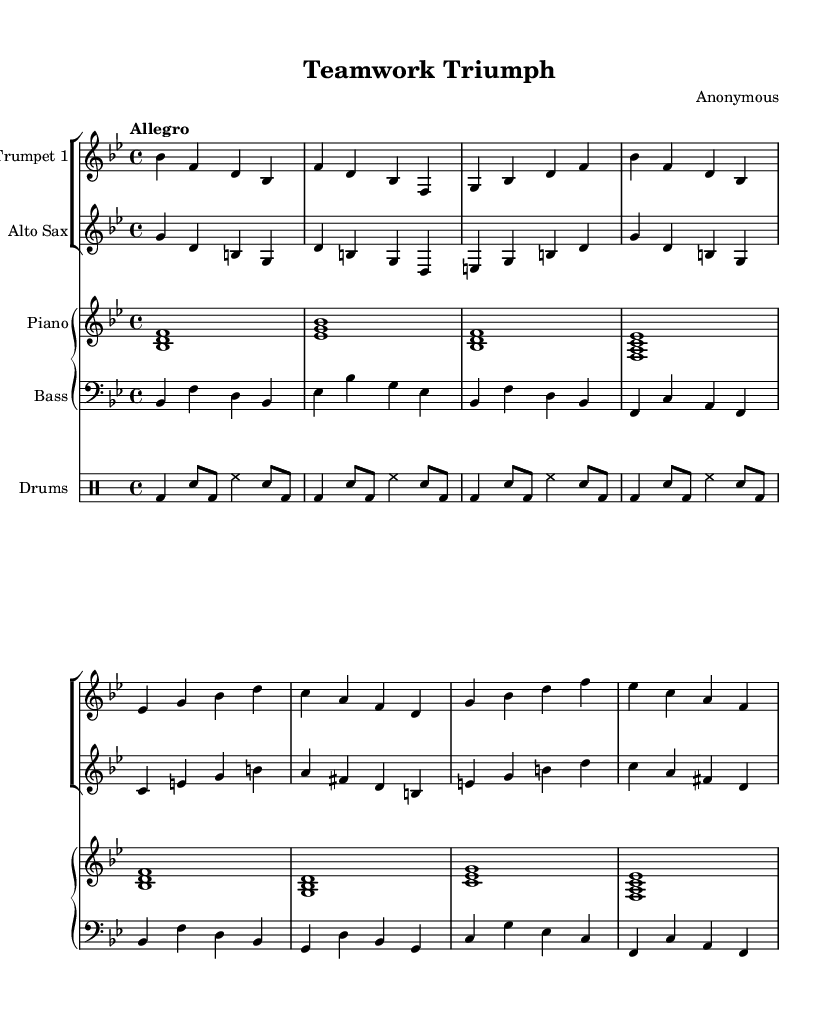What is the key signature of this music? The key signature has two flats, indicated by the presence of B flat and E flat notes in the scale. This identifies the piece as being in B flat major.
Answer: B flat major What is the time signature of the piece? The time signature is indicated at the beginning of the score and is clearly marked as 4/4, meaning there are four beats in each measure.
Answer: 4/4 What is the tempo marking for the composition? The tempo marking appears above the staff and is written as "Allegro," which indicates a fast, lively pace for the music.
Answer: Allegro Which instrument plays the melody primarily throughout the piece? The trumpet, noted as "Trumpet 1," consistently carries the main melodic line, as seen in the first staff of the score.
Answer: Trumpet 1 How many measures are there in the score? Counting each of the measures as indicated by the bar lines, there are a total of eight measures represented in the musical excerpt.
Answer: Eight What is the last note in the piano part? The last note in the piano part, identified at the end of the last measure, is an E flat, as indicated by the notes written in the final chord of the piano staff.
Answer: E flat How many instruments are featured in this music? The score includes a total of four distinct instruments: Trumpet 1, Alto Sax, Piano, and Drums. This can be determined by the different staves present in the score.
Answer: Four 